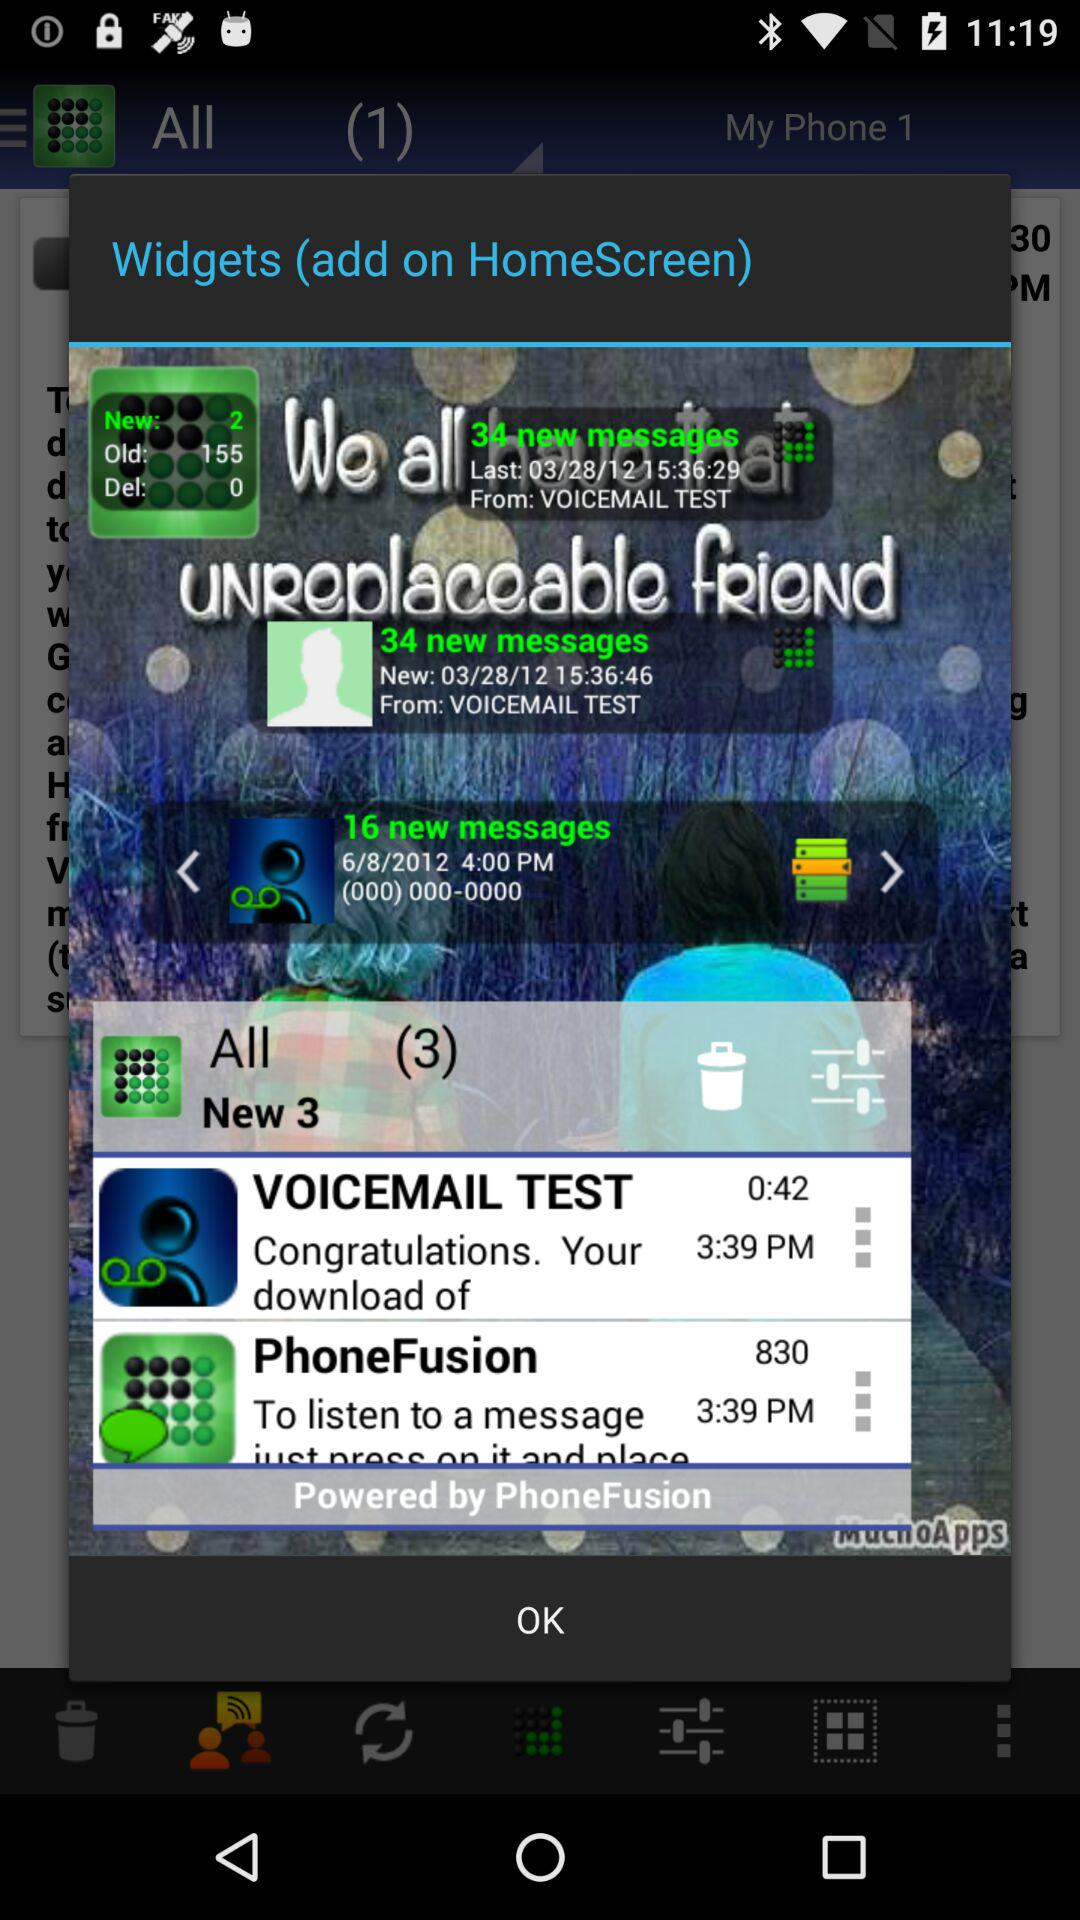At what time was the message from "PhoneFusion" received? The message from "PhoneFusion" was received at 3:39 p.m. 